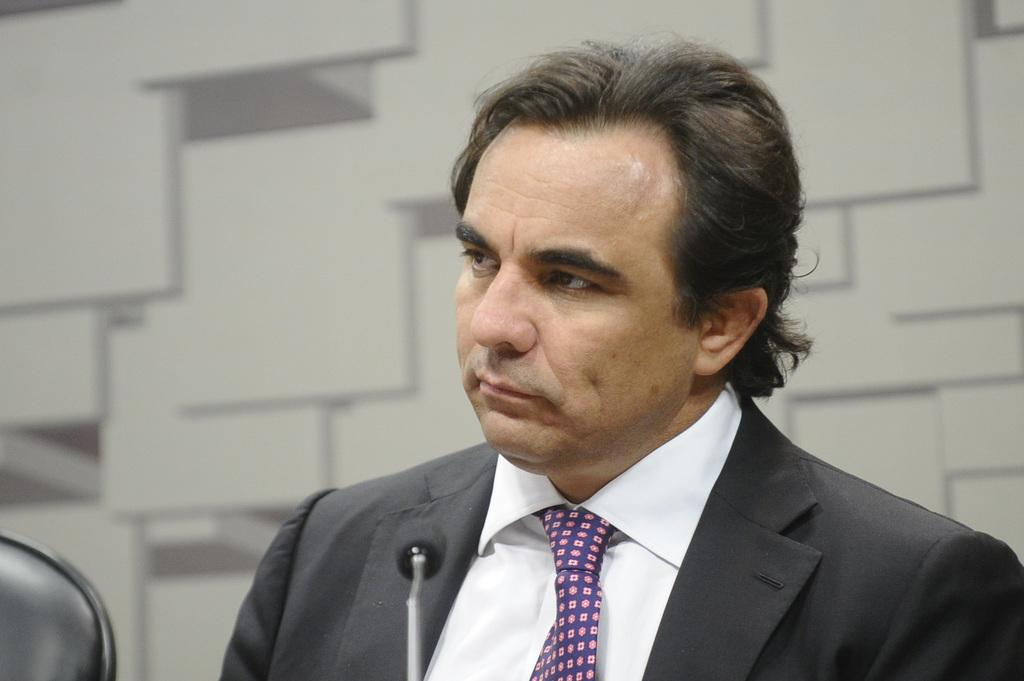What is the main subject of the image? The main subject of the image is a man. What is the man wearing in the image? The man is wearing a blazer and a tie. What object is in front of the man? There is a microphone (mic) in front of the man. What can be seen in the background of the image? There is a wall in the background of the image. What type of vegetable is the man holding in the image? There is no vegetable present in the image; the man is not holding anything. Can you tell me how the man is playing basketball in the image? There is no basketball or any indication of the man playing basketball in the image. 